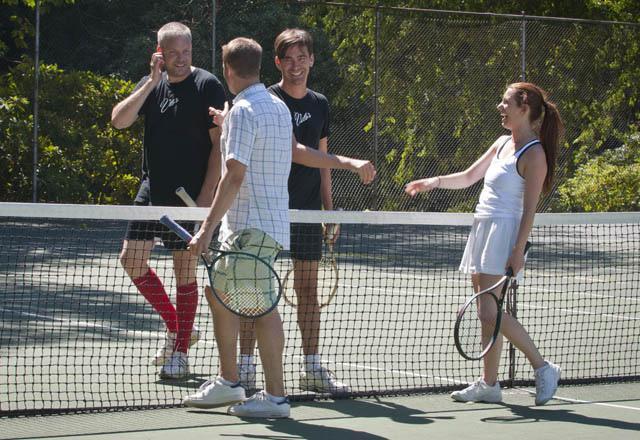What is the relationship of the man wearing white checker shirt to the woman wearing white skirt in this situation?
Choose the correct response, then elucidate: 'Answer: answer
Rationale: rationale.'
Options: Coworker, competitor, teammate, coach. Answer: teammate.
Rationale: They're teammates. How much farther can the red socks be pulled up normally?
Choose the correct response and explain in the format: 'Answer: answer
Rationale: rationale.'
Options: To calves, to head, not much, to stomach. Answer: not much.
Rationale: A man is on a tennis court with socks pulled up nearly to his knees. knee socks come to just below most people's knees. 